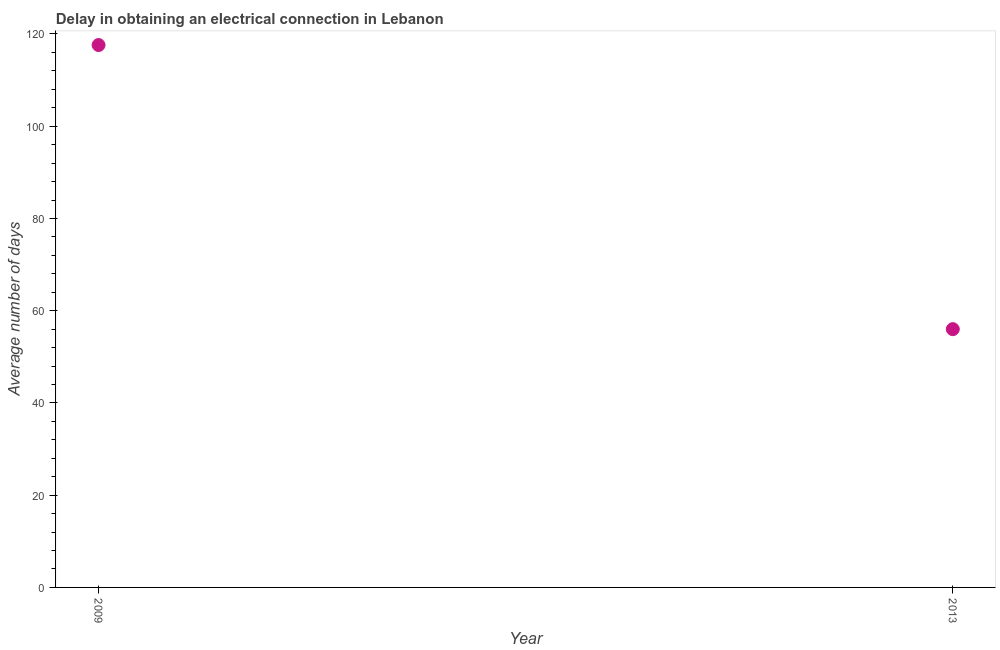Across all years, what is the maximum dalay in electrical connection?
Offer a very short reply. 117.6. Across all years, what is the minimum dalay in electrical connection?
Offer a very short reply. 56. In which year was the dalay in electrical connection maximum?
Your answer should be compact. 2009. In which year was the dalay in electrical connection minimum?
Provide a short and direct response. 2013. What is the sum of the dalay in electrical connection?
Ensure brevity in your answer.  173.6. What is the difference between the dalay in electrical connection in 2009 and 2013?
Make the answer very short. 61.6. What is the average dalay in electrical connection per year?
Keep it short and to the point. 86.8. What is the median dalay in electrical connection?
Your answer should be very brief. 86.8. What is the ratio of the dalay in electrical connection in 2009 to that in 2013?
Your response must be concise. 2.1. In how many years, is the dalay in electrical connection greater than the average dalay in electrical connection taken over all years?
Provide a short and direct response. 1. Does the dalay in electrical connection monotonically increase over the years?
Give a very brief answer. No. How many years are there in the graph?
Ensure brevity in your answer.  2. What is the difference between two consecutive major ticks on the Y-axis?
Offer a very short reply. 20. Are the values on the major ticks of Y-axis written in scientific E-notation?
Your response must be concise. No. Does the graph contain any zero values?
Provide a succinct answer. No. Does the graph contain grids?
Your response must be concise. No. What is the title of the graph?
Provide a short and direct response. Delay in obtaining an electrical connection in Lebanon. What is the label or title of the Y-axis?
Offer a terse response. Average number of days. What is the Average number of days in 2009?
Give a very brief answer. 117.6. What is the difference between the Average number of days in 2009 and 2013?
Your answer should be very brief. 61.6. 